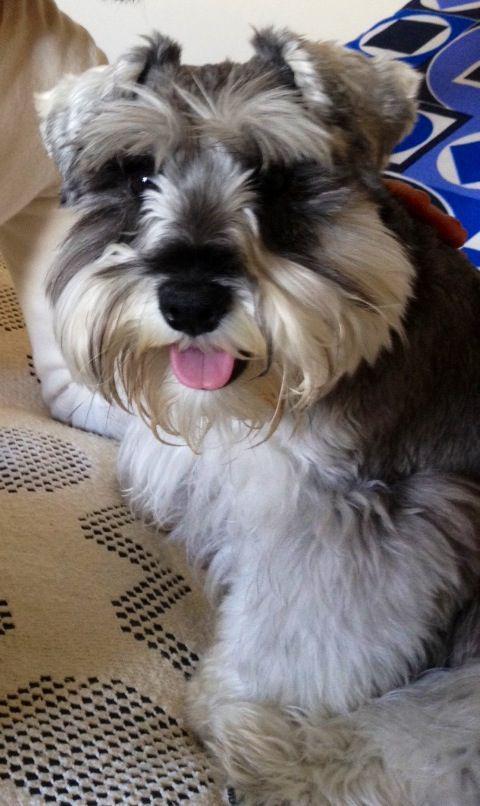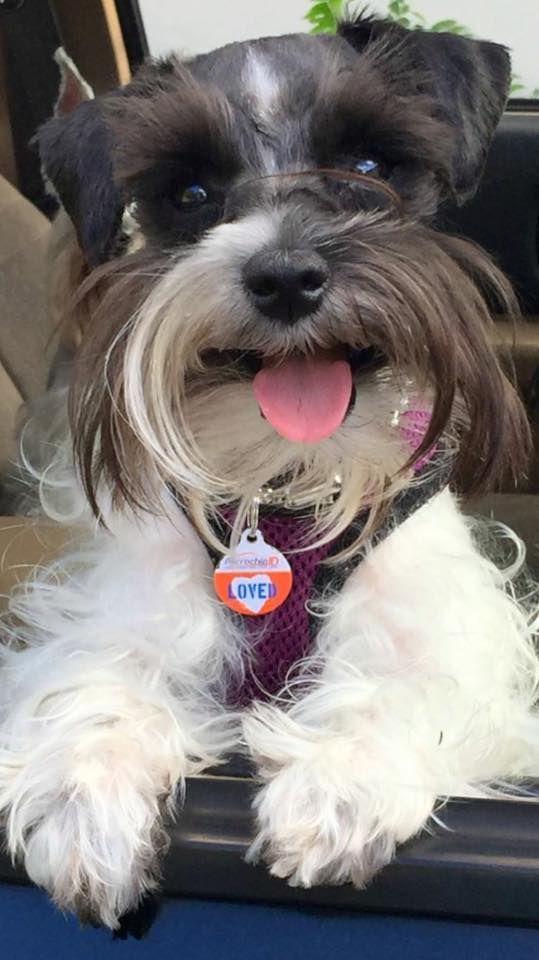The first image is the image on the left, the second image is the image on the right. For the images displayed, is the sentence "The dog in at least one of the images has its tongue hanging out." factually correct? Answer yes or no. Yes. The first image is the image on the left, the second image is the image on the right. For the images shown, is this caption "Each image shows a single schnauzer that is not in costume, and at least one image features a dog with its tongue sticking out." true? Answer yes or no. Yes. 